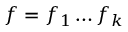<formula> <loc_0><loc_0><loc_500><loc_500>f = f _ { 1 } \dots f _ { k }</formula> 